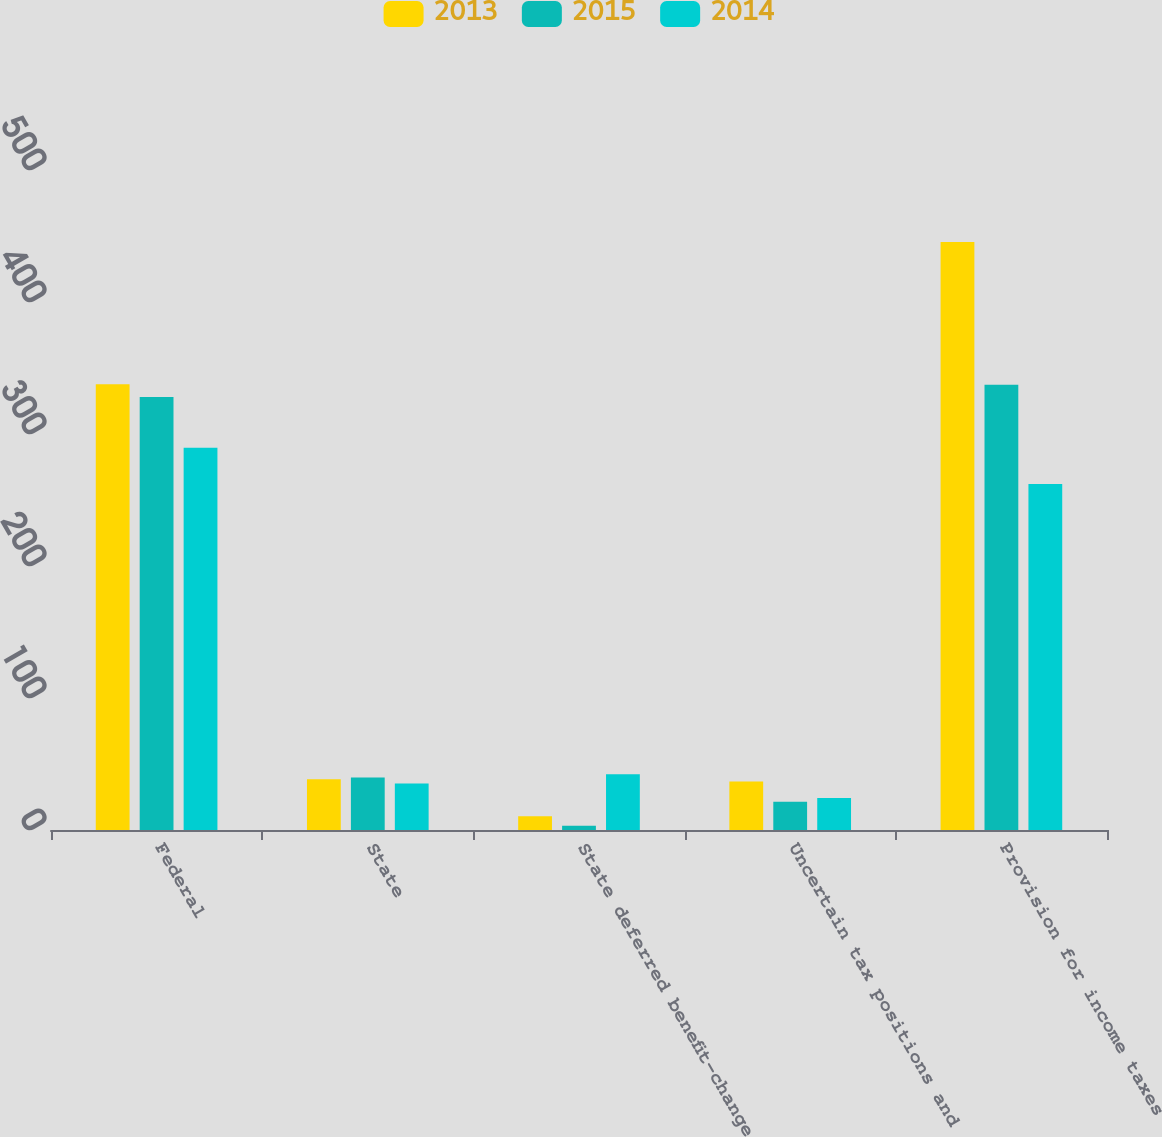<chart> <loc_0><loc_0><loc_500><loc_500><stacked_bar_chart><ecel><fcel>Federal<fcel>State<fcel>State deferred benefit-change<fcel>Uncertain tax positions and<fcel>Provision for income taxes<nl><fcel>2013<fcel>337.6<fcel>38.4<fcel>10.5<fcel>36.7<fcel>445.5<nl><fcel>2015<fcel>328.1<fcel>39.7<fcel>3.2<fcel>21.4<fcel>337.4<nl><fcel>2014<fcel>289.6<fcel>35.3<fcel>42.3<fcel>24.3<fcel>262.1<nl></chart> 